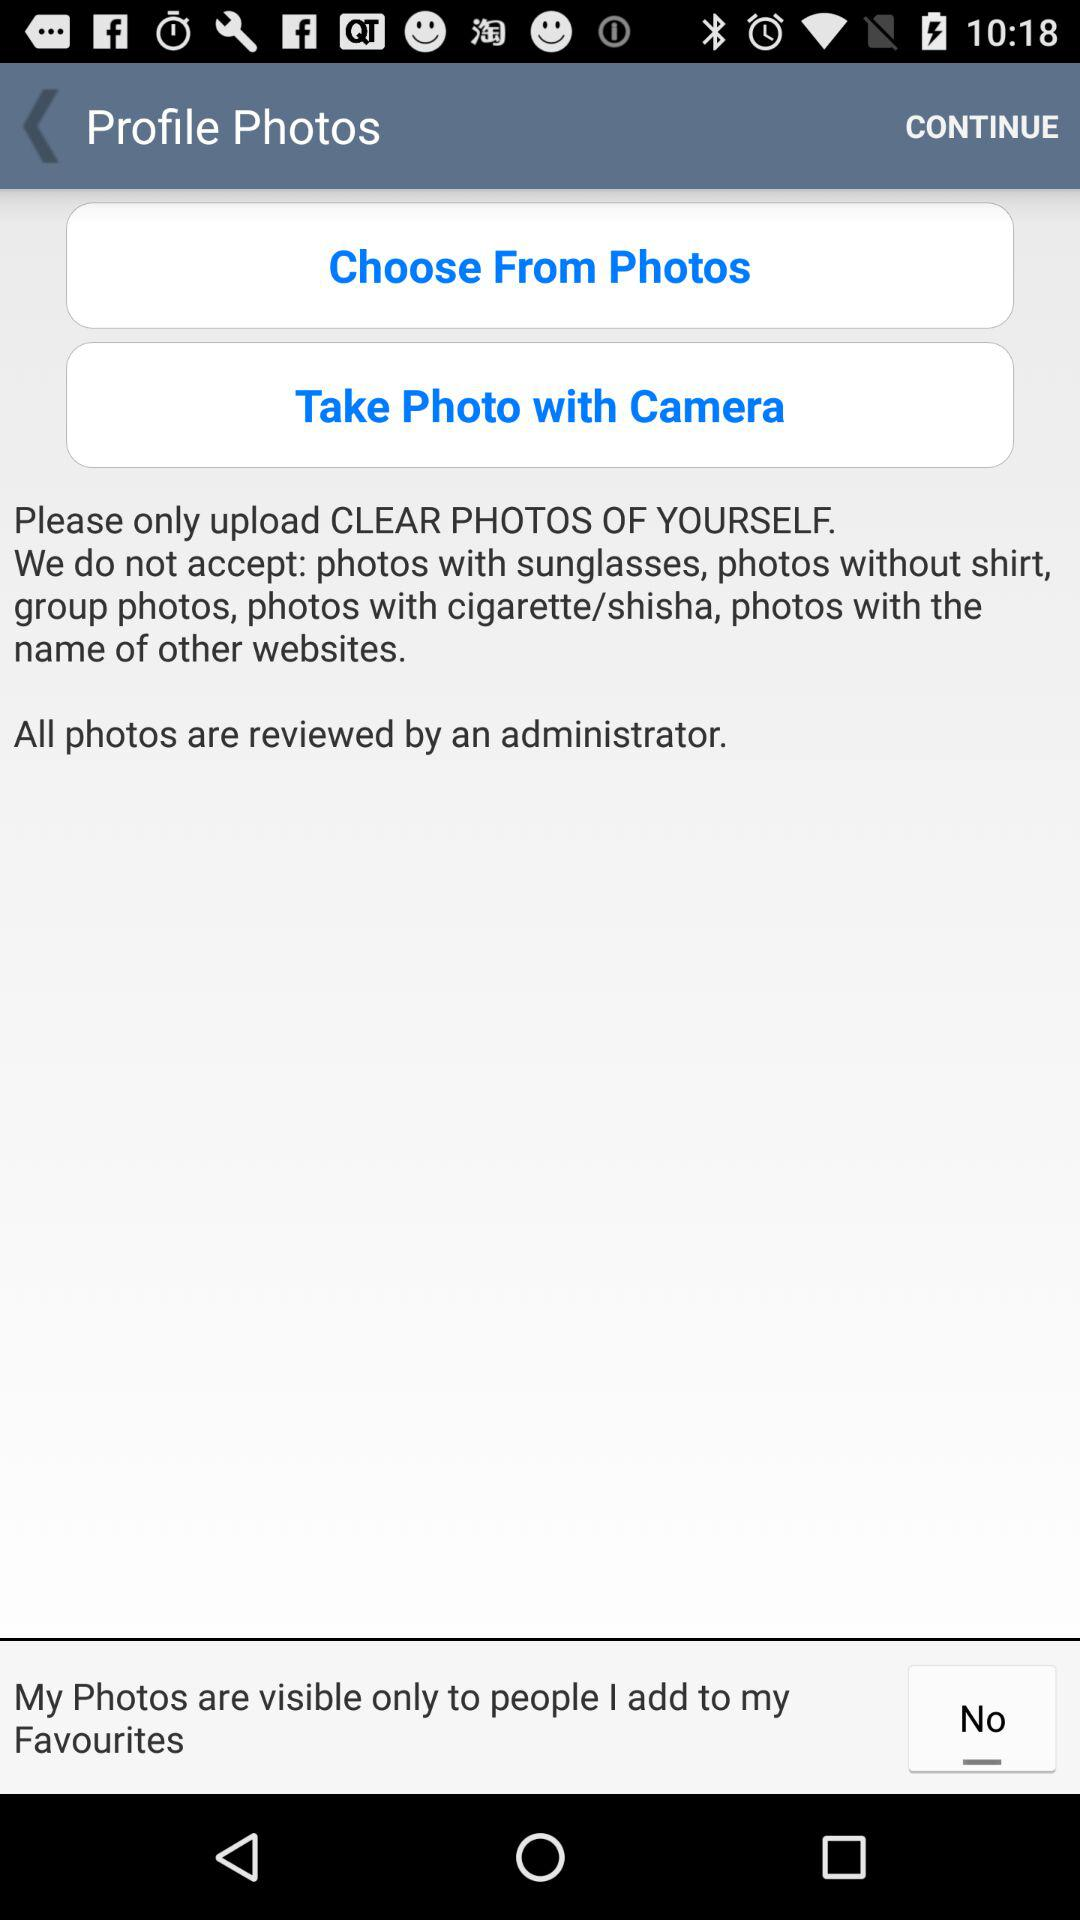What kinds of photos are not accepted? The types of photos that are not accepted are "photos with sunglasses, photos without shirt group photos, photos with cigarette/shisha, photos with the name of other websites". 